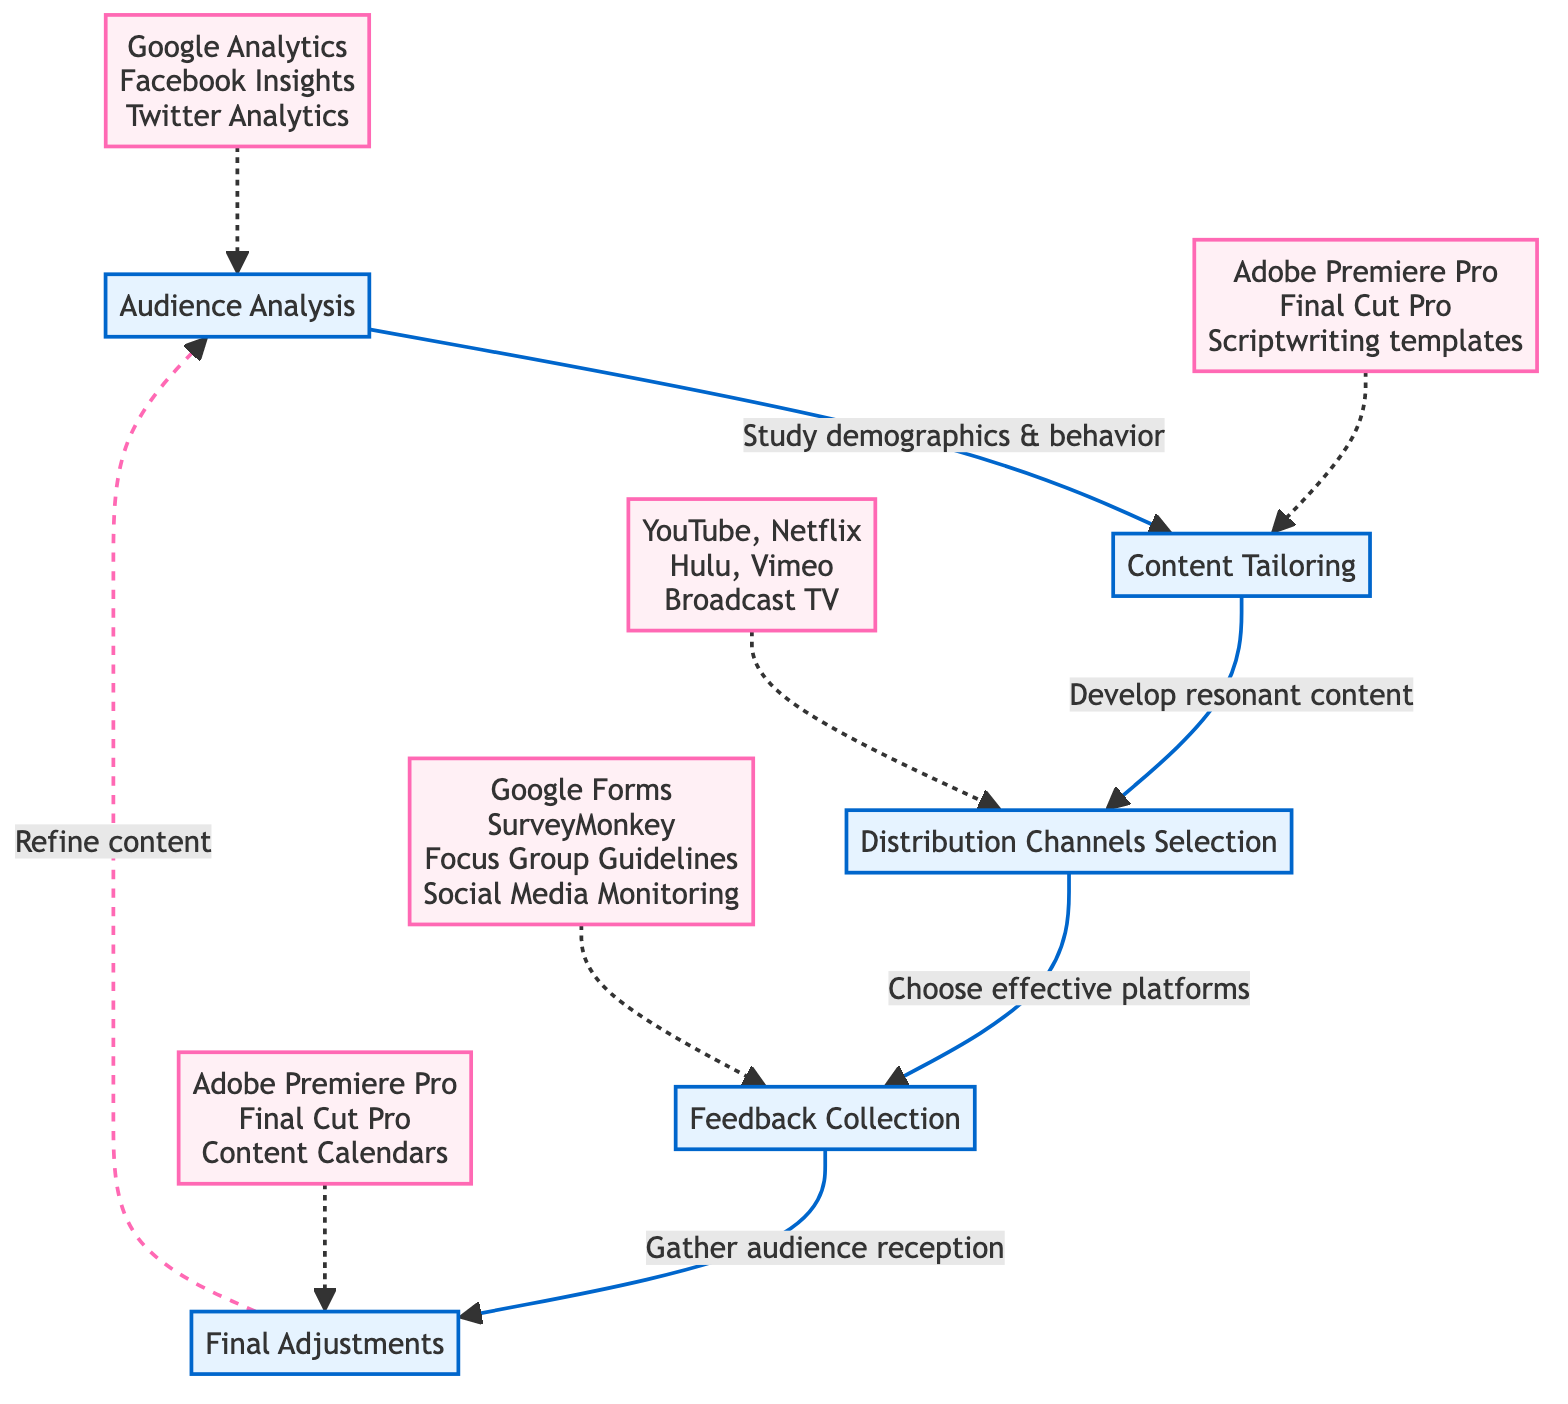What is the first step in the diagram? The first step is labeled "Audience Analysis," which is identified at the beginning of the flow chart. This step is essential as it initiates the process of engaging with diverse audiences.
Answer: Audience Analysis How many main steps are there in the flowchart? By counting the steps represented in the flowchart, we find there are five main steps outlined in the instruction process.
Answer: Five What materials are used for Audience Analysis? The materials associated with "Audience Analysis" include Google Analytics, Facebook Insights, and Twitter Analytics, which are all noted in the diagram.
Answer: Google Analytics, Facebook Insights, Twitter Analytics What is the connection between Content Tailoring and Distribution Channels Selection? The flowchart indicates that Content Tailoring leads directly to Distribution Channels Selection, meaning that after content is tailored, the next step is to choose effective media platforms for the content.
Answer: Develop resonant content How is feedback collected according to the diagram? The diagram details that feedback is collected through surveys, focus groups, and social media comments, which are listed under the "Feedback Collection" step.
Answer: Surveys, focus groups, social media comments Which materials are used in the Final Adjustments step? The materials utilized in the "Final Adjustments" step include Adobe Premiere Pro, Final Cut Pro, and Content Calendars as shown in the diagram.
Answer: Adobe Premiere Pro, Final Cut Pro, Content Calendars What do you need to do after collecting feedback? After collecting feedback, the next action required is to refine content to align better with audience expectations and enhance engagement, which is described in the "Final Adjustments" step.
Answer: Refine content Which step follows Distribution Channels Selection? According to the flowchart, the step that follows Distribution Channels Selection is "Feedback Collection," indicating the need to gather audience input after distributing content.
Answer: Feedback Collection What tools can be used for gathering feedback? Tools for gathering feedback according to the diagram include Google Forms, SurveyMonkey, Focus Group Guidelines, and Social Media Monitoring Tools.
Answer: Google Forms, SurveyMonkey, Focus Group Guidelines, Social Media Monitoring Tools 